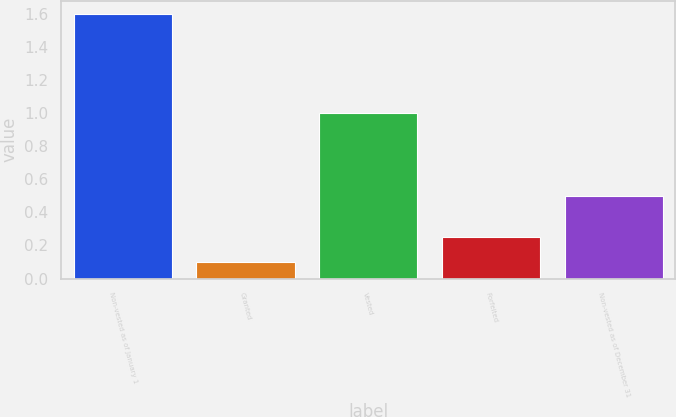<chart> <loc_0><loc_0><loc_500><loc_500><bar_chart><fcel>Non-vested as of January 1<fcel>Granted<fcel>Vested<fcel>Forfeited<fcel>Non-vested as of December 31<nl><fcel>1.6<fcel>0.1<fcel>1<fcel>0.25<fcel>0.5<nl></chart> 